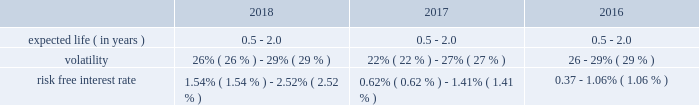Table of contents adobe inc .
Notes to consolidated financial statements ( continued ) stock options the 2003 plan allows us to grant options to all employees , including executive officers , outside consultants and non- employee directors .
This plan will continue until the earlier of ( i ) termination by the board or ( ii ) the date on which all of the shares available for issuance under the plan have been issued and restrictions on issued shares have lapsed .
Option vesting periods used in the past were generally four years and expire seven years from the effective date of grant .
We eliminated the use of stock option grants for all employees and non-employee directors but may choose to issue stock options in the future .
Performance share programs our 2018 , 2017 and 2016 performance share programs aim to help focus key employees on building stockholder value , provide significant award potential for achieving outstanding company performance and enhance the ability of the company to attract and retain highly talented and competent individuals .
The executive compensation committee of our board of directors approves the terms of each of our performance share programs , including the award calculation methodology , under the terms of our 2003 plan .
Shares may be earned based on the achievement of an objective relative total stockholder return measured over a three-year performance period .
Performance share awards will be awarded and fully vest upon the later of the executive compensation committee's certification of the level of achievement or the three-year anniversary of each grant .
Program participants generally have the ability to receive up to 200% ( 200 % ) of the target number of shares originally granted .
On january 24 , 2018 , the executive compensation committee approved the 2018 performance share program , the terms of which are similar to prior year performance share programs as discussed above .
As of november 30 , 2018 , the shares awarded under our 2018 , 2017 and 2016 performance share programs are yet to be achieved .
Issuance of shares upon exercise of stock options , vesting of restricted stock units and performance shares , and purchases of shares under the espp , we will issue treasury stock .
If treasury stock is not available , common stock will be issued .
In order to minimize the impact of on-going dilution from exercises of stock options and vesting of restricted stock units and performance shares , we instituted a stock repurchase program .
See note 12 for information regarding our stock repurchase programs .
Valuation of stock-based compensation stock-based compensation cost is measured at the grant date based on the fair value of the award .
Our performance share awards are valued using a monte carlo simulation model .
The fair value of the awards are fixed at grant date and amortized over the longer of the remaining performance or service period .
We use the black-scholes option pricing model to determine the fair value of espp shares .
The determination of the fair value of stock-based payment awards on the date of grant using an option pricing model is affected by our stock price as well as assumptions regarding a number of complex and subjective variables .
These variables include our expected stock price volatility over the expected term of the awards , actual and projected employee stock option exercise behaviors , a risk-free interest rate and any expected dividends .
The expected term of espp shares is the average of the remaining purchase periods under each offering period .
The assumptions used to value employee stock purchase rights were as follows: .

What is the average volatility used to value employee stock purchase rights in 2017? 
Computations: ((22% + 27%) / 2)
Answer: 0.245. 